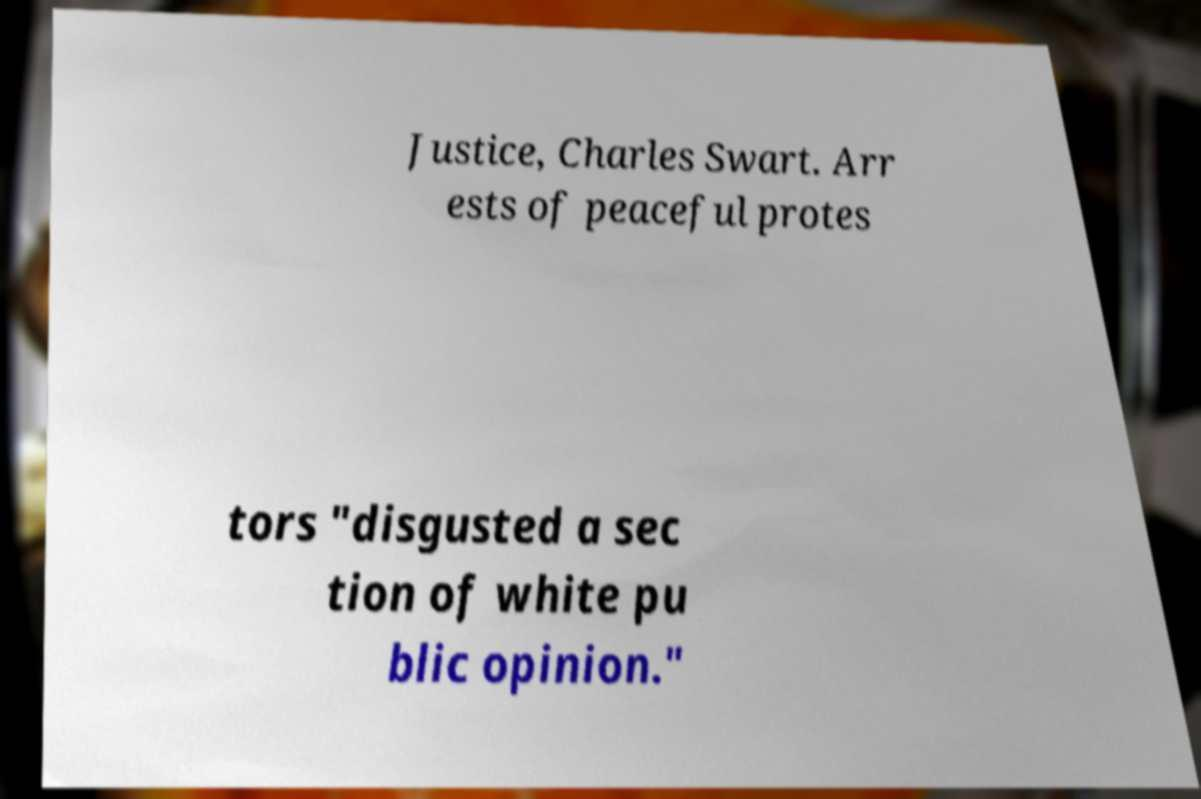I need the written content from this picture converted into text. Can you do that? Justice, Charles Swart. Arr ests of peaceful protes tors "disgusted a sec tion of white pu blic opinion." 